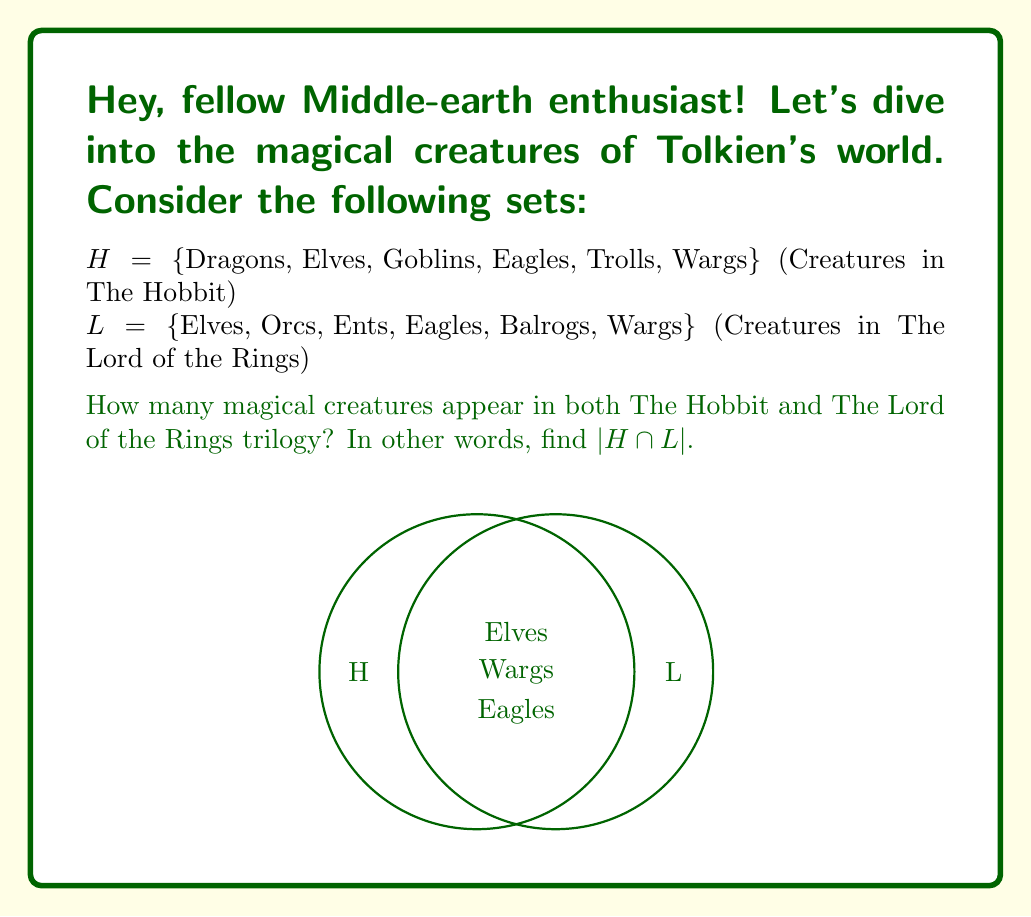Give your solution to this math problem. Let's approach this step-by-step:

1) To find the intersection of sets H and L, we need to identify the elements that are present in both sets.

2) Let's go through each element:
   - Dragons: Only in H
   - Elves: In both H and L
   - Goblins: Only in H
   - Eagles: In both H and L
   - Trolls: Only in H
   - Wargs: In both H and L
   - Orcs: Only in L
   - Ents: Only in L
   - Balrogs: Only in L

3) We can see that there are three creatures that appear in both sets: Elves, Eagles, and Wargs.

4) Therefore, $H \cap L = \{$Elves, Eagles, Wargs$\}$

5) The cardinality of this intersection, denoted as $|H \cap L|$, is the number of elements in this set.

6) $|H \cap L| = 3$
Answer: $3$ 